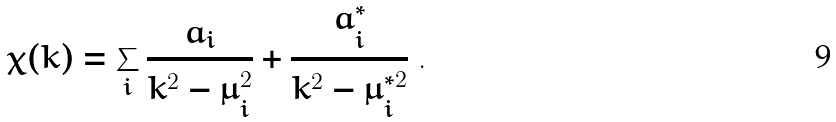<formula> <loc_0><loc_0><loc_500><loc_500>\chi ( k ) = \sum _ { i } \frac { a _ { i } } { k ^ { 2 } - \mu ^ { 2 } _ { i } } + \frac { a ^ { * } _ { i } } { k ^ { 2 } - \mu ^ { * 2 } _ { i } } \ .</formula> 